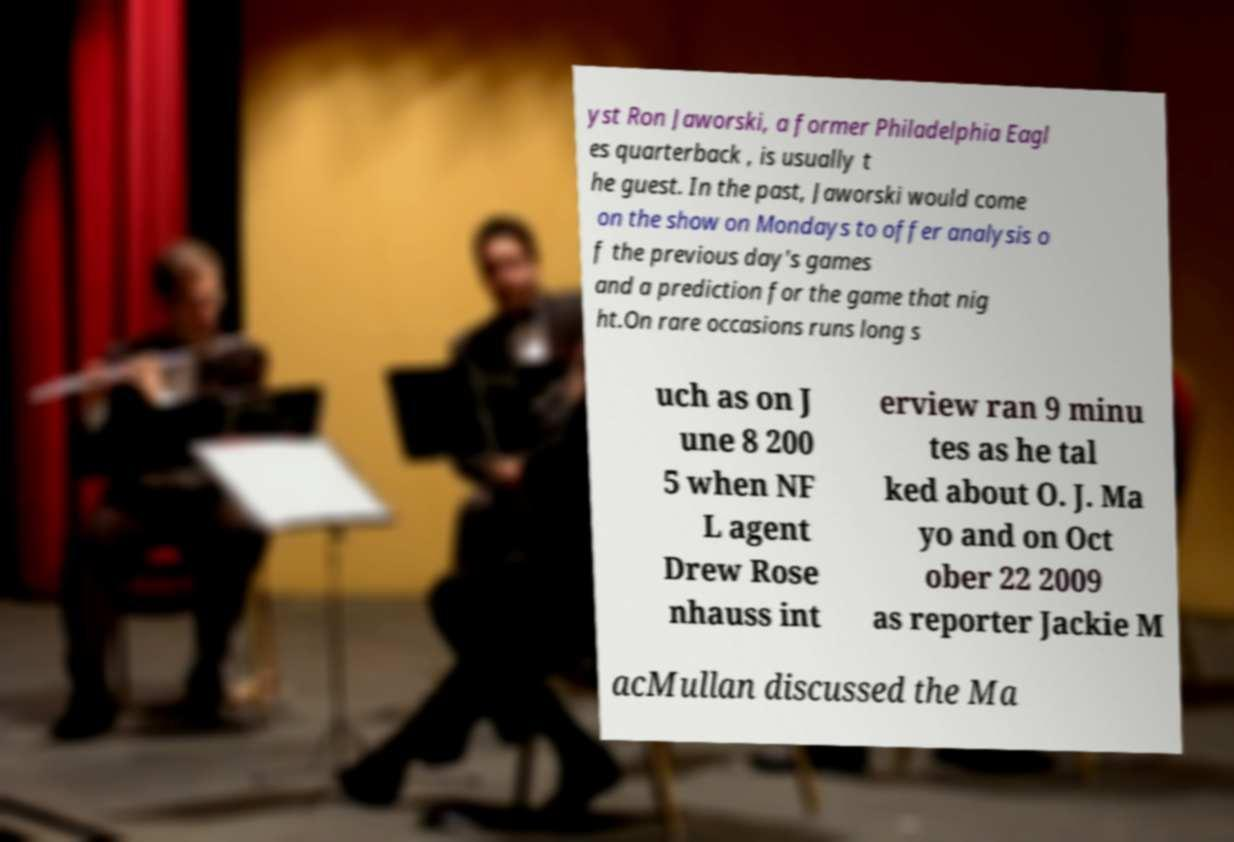Can you read and provide the text displayed in the image?This photo seems to have some interesting text. Can you extract and type it out for me? yst Ron Jaworski, a former Philadelphia Eagl es quarterback , is usually t he guest. In the past, Jaworski would come on the show on Mondays to offer analysis o f the previous day's games and a prediction for the game that nig ht.On rare occasions runs long s uch as on J une 8 200 5 when NF L agent Drew Rose nhauss int erview ran 9 minu tes as he tal ked about O. J. Ma yo and on Oct ober 22 2009 as reporter Jackie M acMullan discussed the Ma 